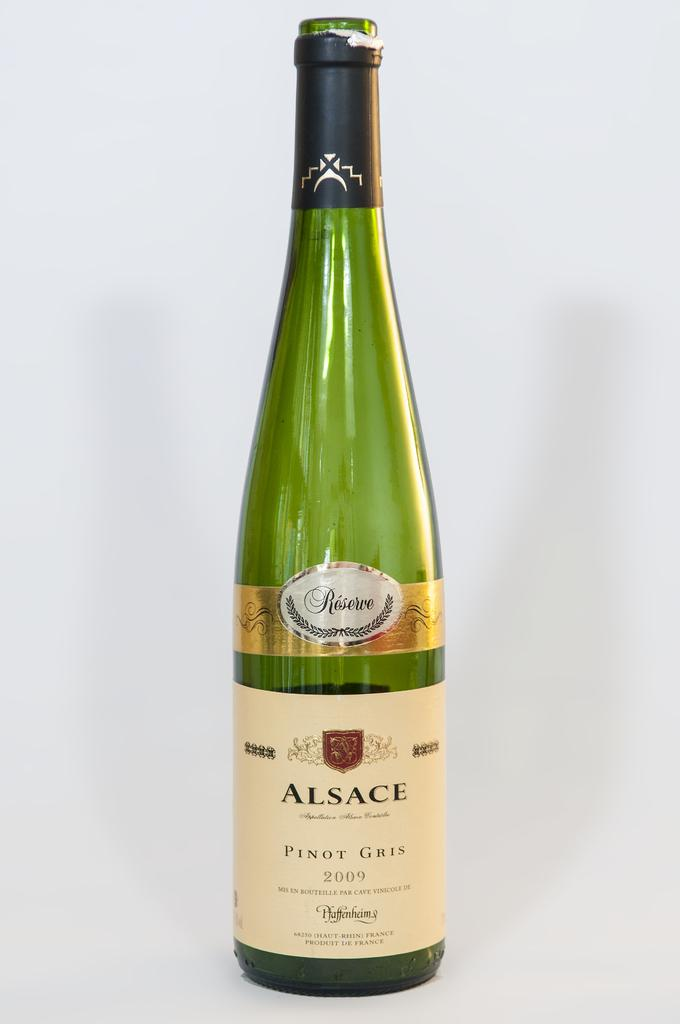<image>
Offer a succinct explanation of the picture presented. A bottle of Pinot Gris wine was made in the year 2009. 